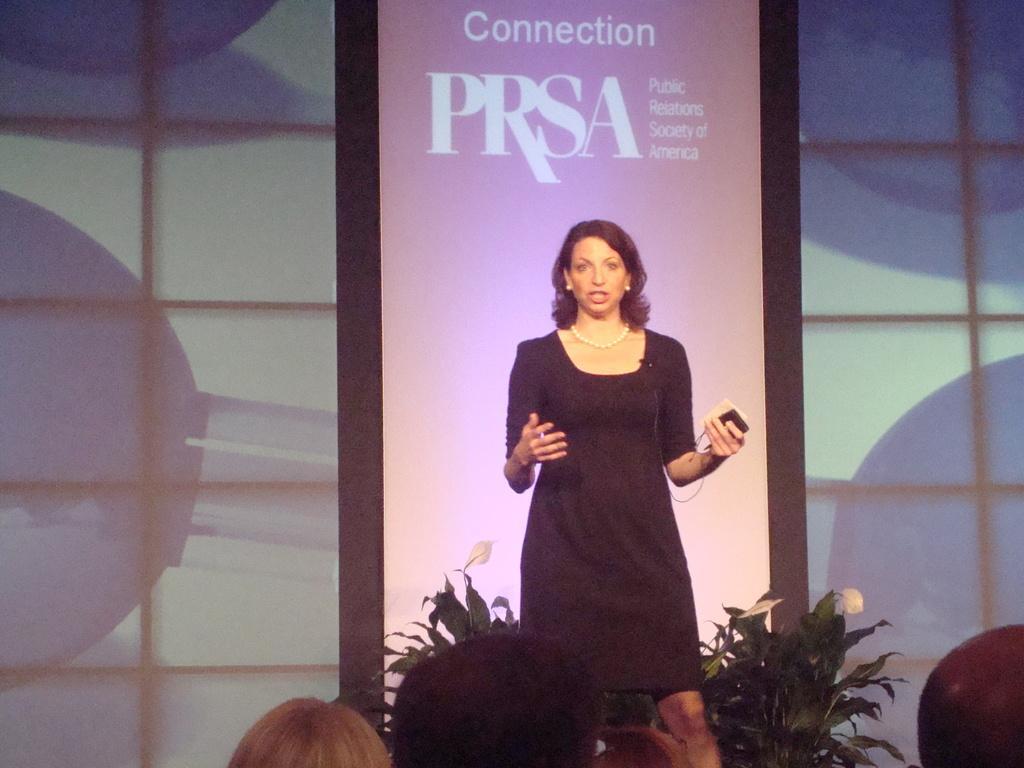In one or two sentences, can you explain what this image depicts? In the picture there is a woman standing and talking, she is holding an object in her hand, behind her there is a banner with the text, there are plants. 